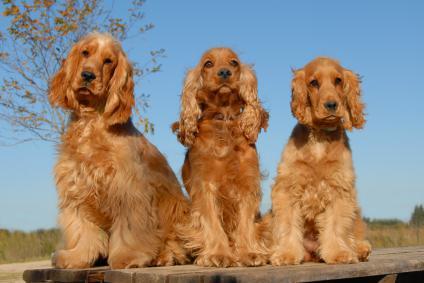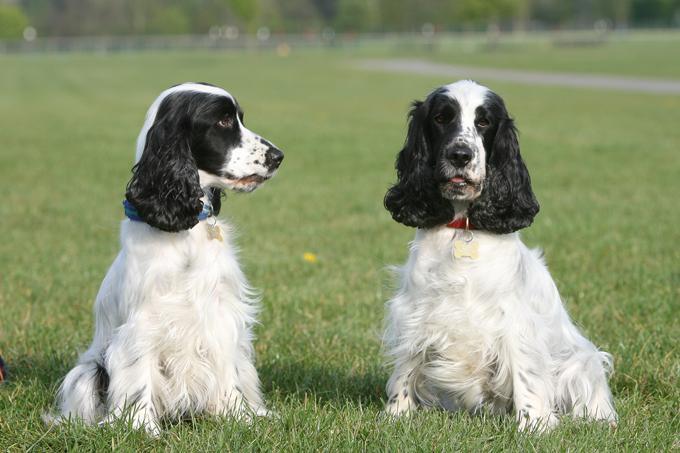The first image is the image on the left, the second image is the image on the right. Analyze the images presented: Is the assertion "An image shows one reclining dog with a paw on an object." valid? Answer yes or no. No. 